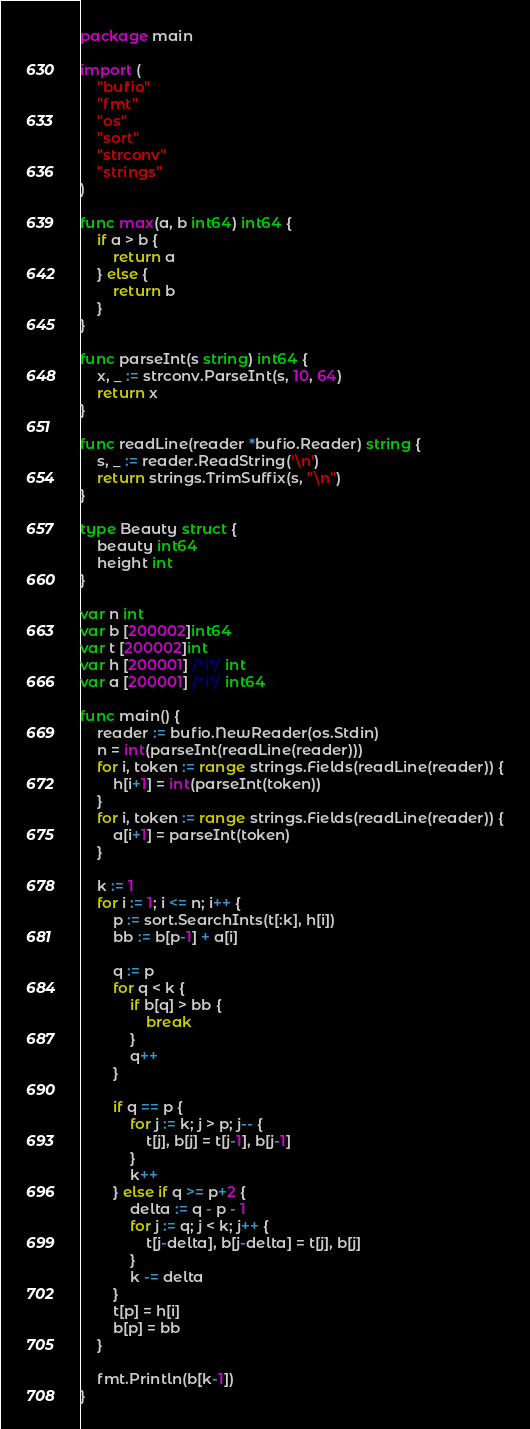Convert code to text. <code><loc_0><loc_0><loc_500><loc_500><_Go_>package main

import (
	"bufio"
	"fmt"
	"os"
	"sort"
	"strconv"
	"strings"
)

func max(a, b int64) int64 {
	if a > b {
		return a
	} else {
		return b
	}
}

func parseInt(s string) int64 {
	x, _ := strconv.ParseInt(s, 10, 64)
	return x
}

func readLine(reader *bufio.Reader) string {
	s, _ := reader.ReadString('\n')
	return strings.TrimSuffix(s, "\n")
}

type Beauty struct {
	beauty int64
	height int
}

var n int
var b [200002]int64
var t [200002]int
var h [200001] /*i*/ int
var a [200001] /*i*/ int64

func main() {
	reader := bufio.NewReader(os.Stdin)
	n = int(parseInt(readLine(reader)))
	for i, token := range strings.Fields(readLine(reader)) {
		h[i+1] = int(parseInt(token))
	}
	for i, token := range strings.Fields(readLine(reader)) {
		a[i+1] = parseInt(token)
	}

	k := 1
	for i := 1; i <= n; i++ {
		p := sort.SearchInts(t[:k], h[i])
		bb := b[p-1] + a[i]

		q := p
		for q < k {
			if b[q] > bb {
				break
			}
			q++
		}

		if q == p {
			for j := k; j > p; j-- {
				t[j], b[j] = t[j-1], b[j-1]
			}
			k++
		} else if q >= p+2 {
			delta := q - p - 1
			for j := q; j < k; j++ {
				t[j-delta], b[j-delta] = t[j], b[j]
			}
			k -= delta
		}
		t[p] = h[i]
		b[p] = bb
	}

	fmt.Println(b[k-1])
}
</code> 